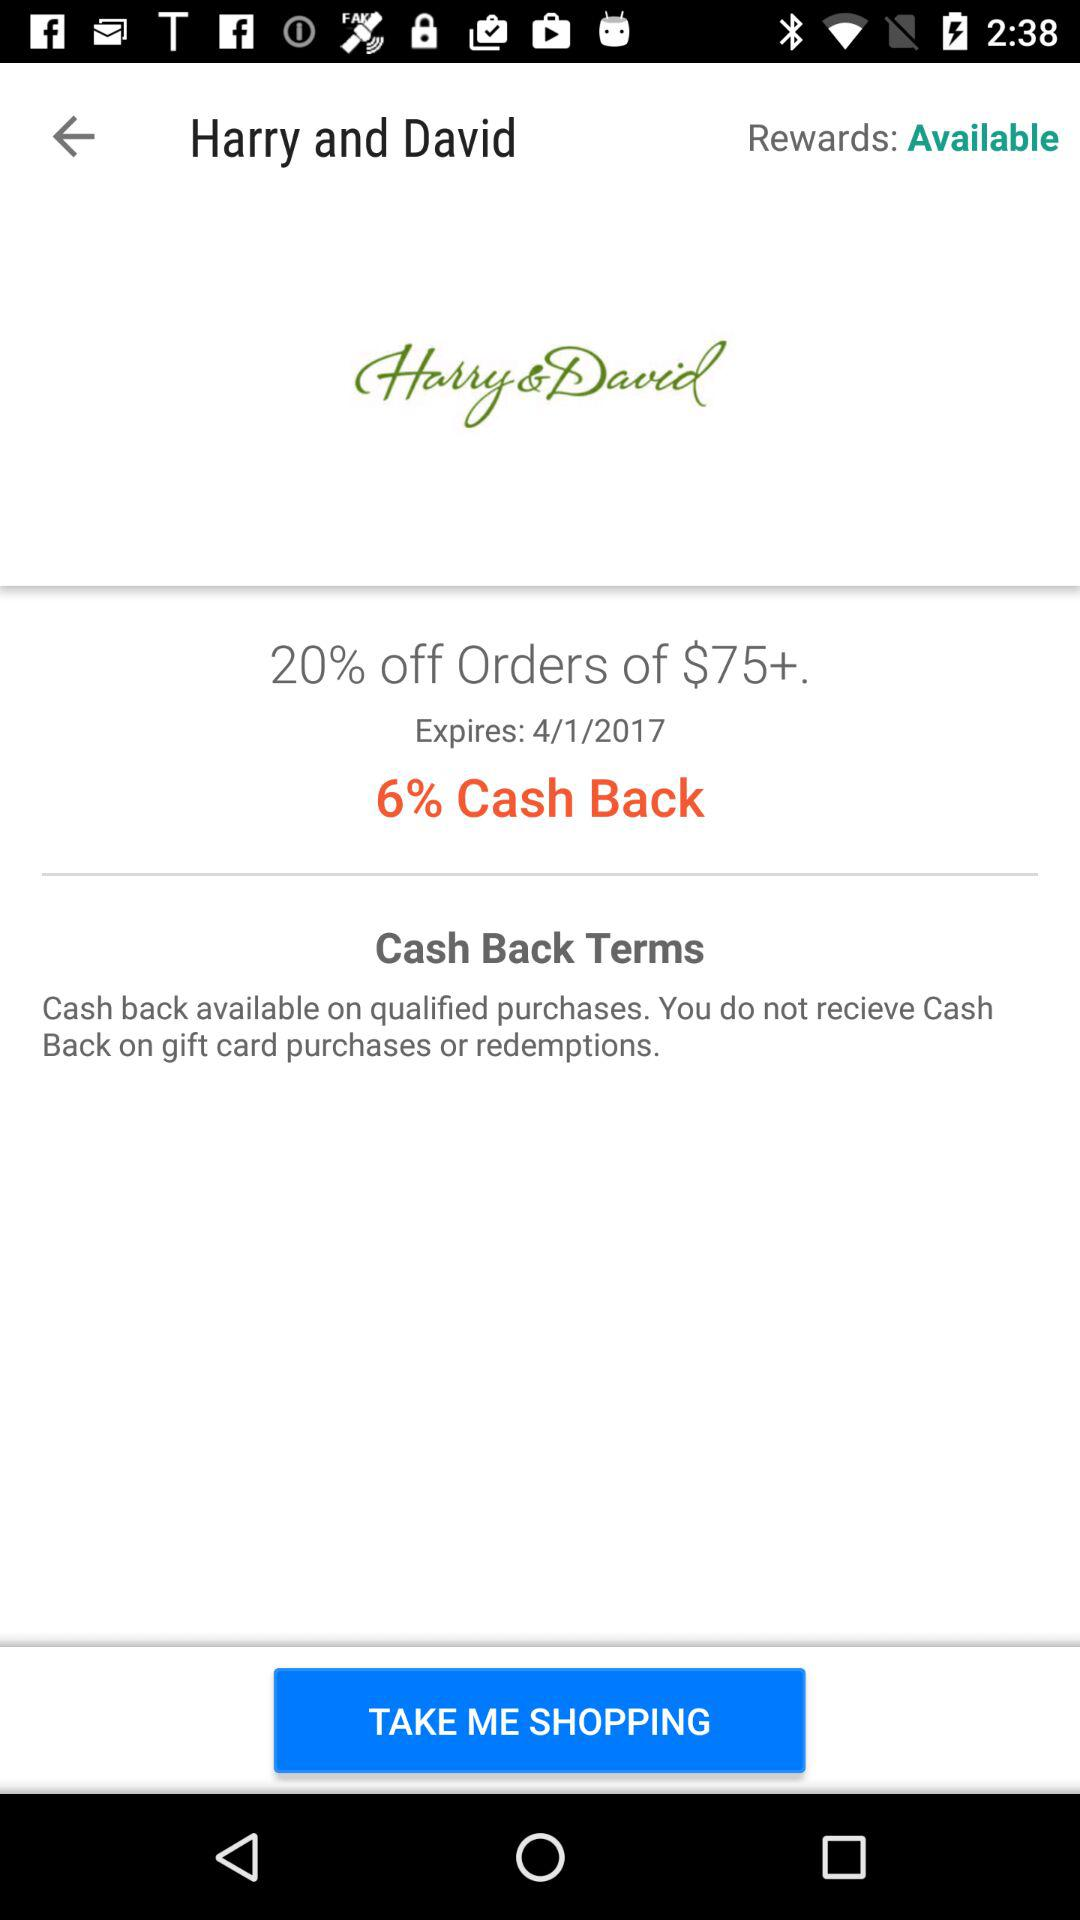How much cash back is available on this offer?
Answer the question using a single word or phrase. 6% 